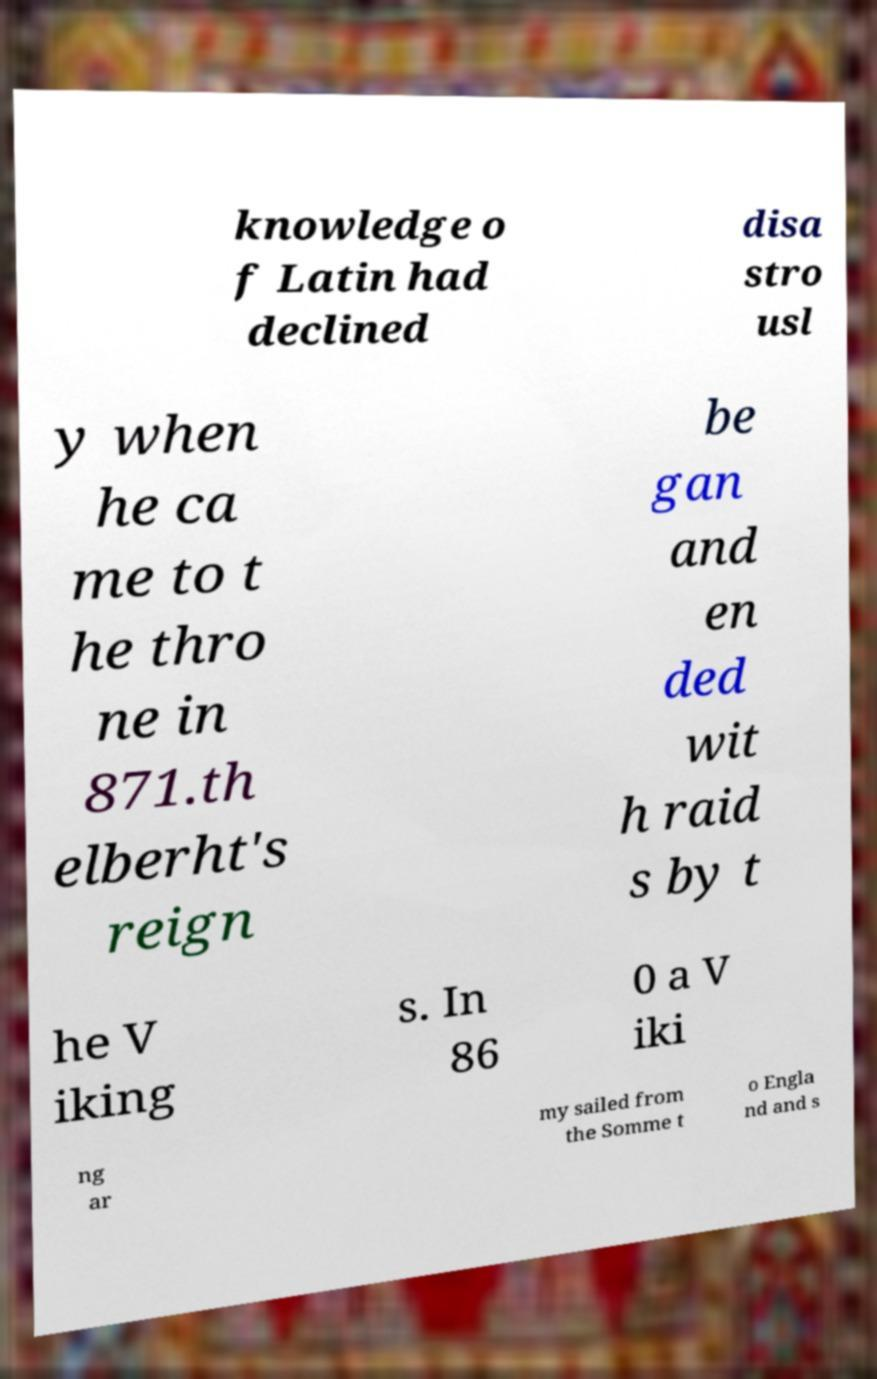Please identify and transcribe the text found in this image. knowledge o f Latin had declined disa stro usl y when he ca me to t he thro ne in 871.th elberht's reign be gan and en ded wit h raid s by t he V iking s. In 86 0 a V iki ng ar my sailed from the Somme t o Engla nd and s 